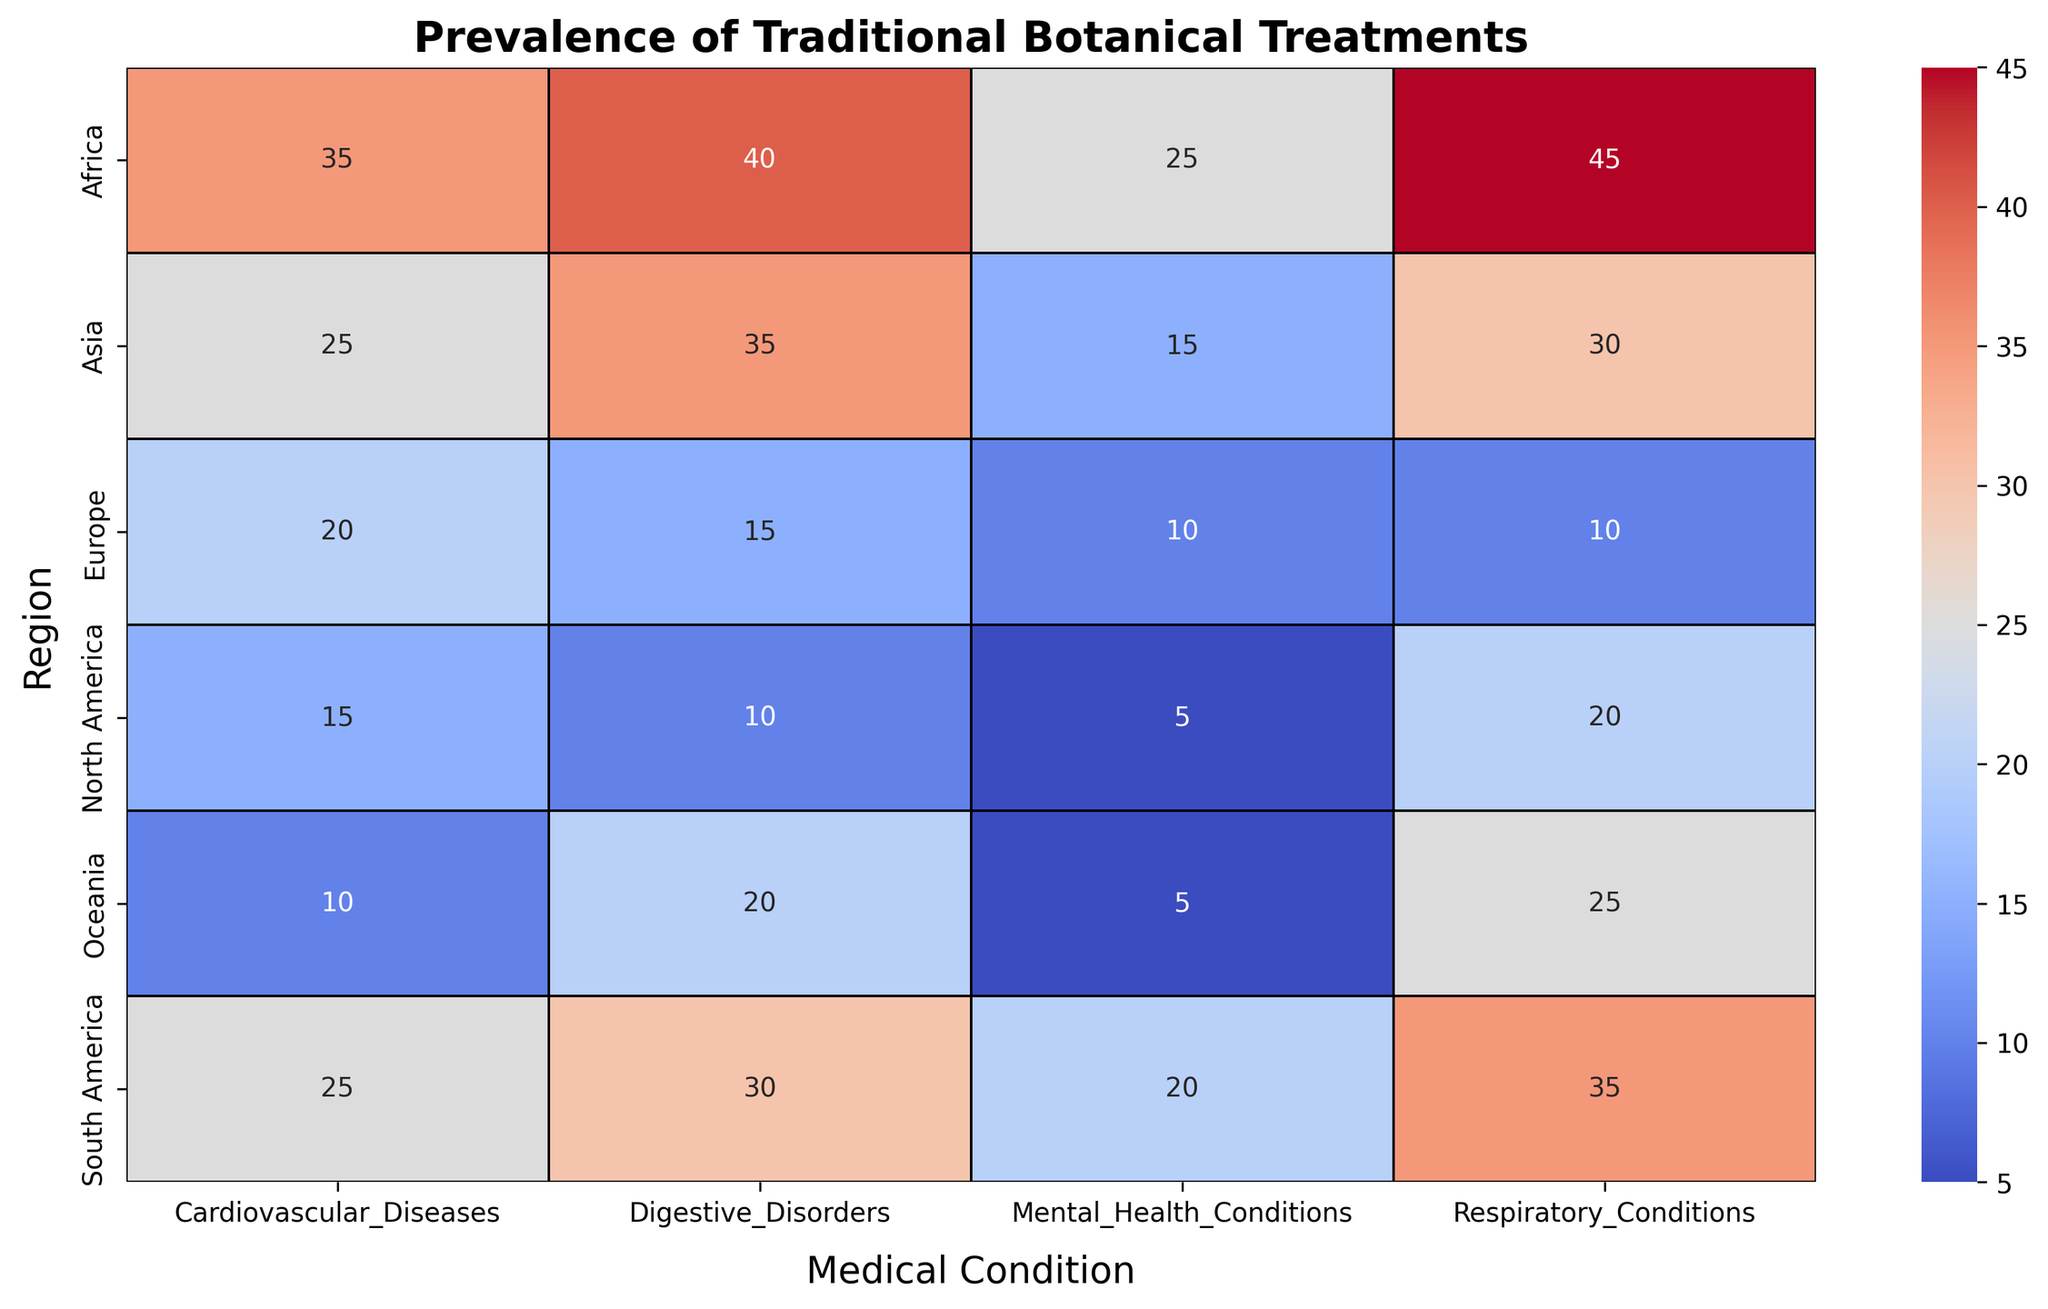What is the most prevalent medical condition in South America according to traditional botanical treatments? In the heatmap, locate the row for South America and compare the values across the different medical conditions. The largest percentage value in the South America row corresponds to Digestive Disorders with 30%.
Answer: Digestive Disorders Which region has the highest prevalence of traditional botanical treatments for Mental Health Conditions? Look at the prevalence values under Mental Health Conditions across all regions and find the highest value. The highest value is 25%, which is in Africa.
Answer: Africa Between Respiratory Conditions and Cardiovascular Diseases, which medical condition has more prevalence in North America? In the North America row, compare the values for Respiratory Conditions and Cardiovascular Diseases. Respiratory Conditions have a prevalence of 20%, which is higher than Cardiovascular Diseases at 15%.
Answer: Respiratory Conditions Calculate the average prevalence of traditional botanical treatments for Cardiovascular Diseases across all regions. Sum the prevalence values for Cardiovascular Diseases across all regions and then divide by the number of regions. The values are [15, 25, 20, 35, 25, 10]. Sum = 130. Average = 130 / 6 = 21.67%.
Answer: 21.67% What is the difference in prevalence between Digestive Disorders and Respiratory Conditions in Africa? In the Africa row, find the values for Digestive Disorders and Respiratory Conditions. Digestive Disorders have 40% and Respiratory Conditions have 45%. The difference is 45% - 40% = 5%.
Answer: 5% How does the prevalence of traditional botanical treatments for Digestive Disorders in Asia compare to that in Europe? Compare the prevalence values for Digestive Disorders between Asia and Europe. Asia has 35% while Europe has 15%. 35% is more than 15%.
Answer: Asia has higher prevalence Visualize the region with the lowest overall prevalence of traditional botanical treatments for all medical conditions combined. Compare the sum of the prevalence values for all medical conditions in each region. North America has the following values: [20, 15, 10, 5], summing to 50. South America: [35, 25, 30, 20] sums to 110. Europe: [10, 20, 15, 10] sums to 55. Africa: [45, 35, 40, 25] sums to 145. Asia: [30, 25, 35, 15] sums to 105. Oceania: [25, 10, 20, 5] sums to 60. The lowest combined prevalence is in North America.
Answer: North America Which region has a higher prevalence of traditional botanical treatments for Cardiovascular Diseases, Africa or Asia? By how much? Compare the values for Cardiovascular Diseases in Africa and Asia. Africa has 35% and Asia has 25%. The difference is 35% - 25% = 10%.
Answer: Africa by 10% Identify the region with the highest single prevalence value across all medical conditions and regions. Scan the heatmap for the highest single percentage value. The highest value is 45%, which corresponds to Respiratory Conditions in Africa.
Answer: Africa for Respiratory Conditions Is the prevalence of traditional botanical treatments for Mental Health Conditions in Oceania more or less than in North America? Compare the values for Mental Health Conditions between Oceania and North America. Oceania has 5% and North America also has 5%. Since both have the same value, the prevalence is equal.
Answer: Equal 